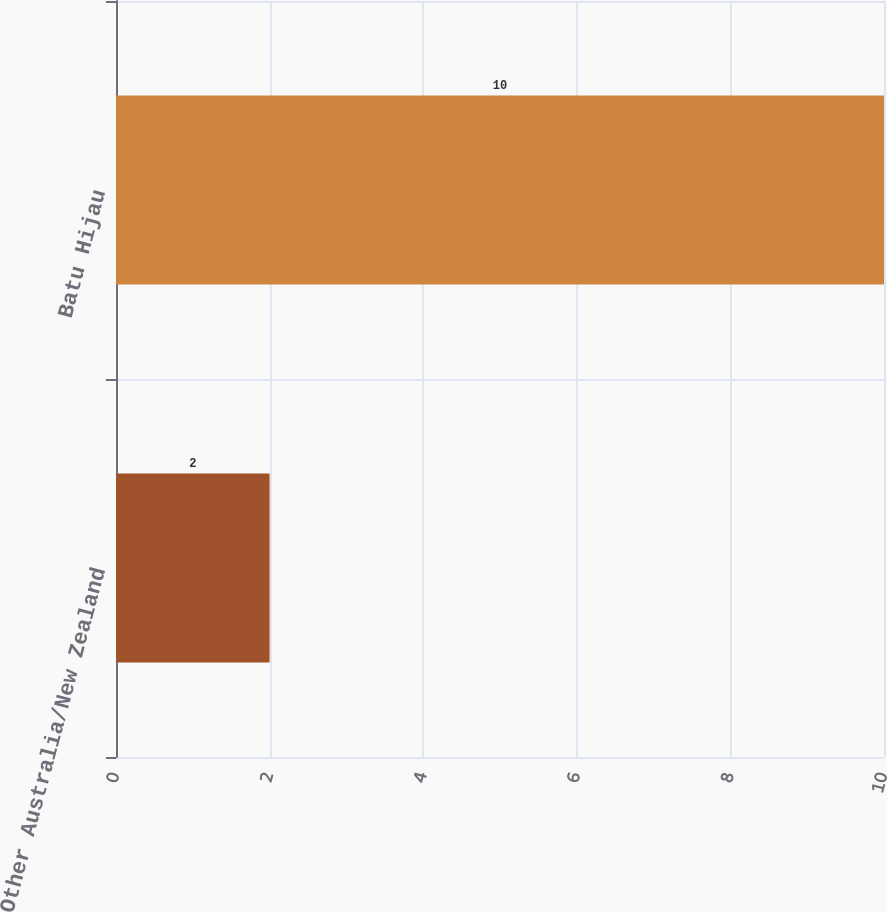Convert chart. <chart><loc_0><loc_0><loc_500><loc_500><bar_chart><fcel>Other Australia/New Zealand<fcel>Batu Hijau<nl><fcel>2<fcel>10<nl></chart> 